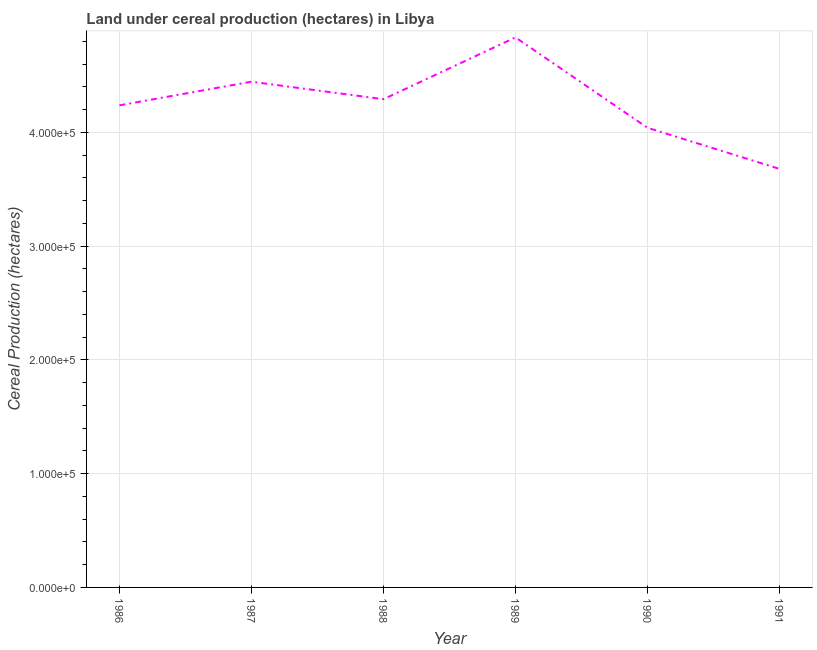What is the land under cereal production in 1989?
Provide a short and direct response. 4.84e+05. Across all years, what is the maximum land under cereal production?
Provide a short and direct response. 4.84e+05. Across all years, what is the minimum land under cereal production?
Keep it short and to the point. 3.68e+05. In which year was the land under cereal production minimum?
Your answer should be very brief. 1991. What is the sum of the land under cereal production?
Provide a succinct answer. 2.55e+06. What is the difference between the land under cereal production in 1986 and 1987?
Make the answer very short. -2.08e+04. What is the average land under cereal production per year?
Your response must be concise. 4.26e+05. What is the median land under cereal production?
Your answer should be very brief. 4.26e+05. In how many years, is the land under cereal production greater than 40000 hectares?
Your answer should be compact. 6. What is the ratio of the land under cereal production in 1986 to that in 1988?
Give a very brief answer. 0.99. Is the land under cereal production in 1986 less than that in 1988?
Provide a short and direct response. Yes. What is the difference between the highest and the second highest land under cereal production?
Provide a succinct answer. 3.90e+04. What is the difference between the highest and the lowest land under cereal production?
Your answer should be very brief. 1.16e+05. Does the land under cereal production monotonically increase over the years?
Make the answer very short. No. How many lines are there?
Your response must be concise. 1. How many years are there in the graph?
Your response must be concise. 6. What is the difference between two consecutive major ticks on the Y-axis?
Your response must be concise. 1.00e+05. Does the graph contain any zero values?
Provide a succinct answer. No. Does the graph contain grids?
Keep it short and to the point. Yes. What is the title of the graph?
Your response must be concise. Land under cereal production (hectares) in Libya. What is the label or title of the X-axis?
Provide a succinct answer. Year. What is the label or title of the Y-axis?
Keep it short and to the point. Cereal Production (hectares). What is the Cereal Production (hectares) in 1986?
Your answer should be very brief. 4.24e+05. What is the Cereal Production (hectares) in 1987?
Give a very brief answer. 4.45e+05. What is the Cereal Production (hectares) of 1988?
Make the answer very short. 4.29e+05. What is the Cereal Production (hectares) of 1989?
Offer a terse response. 4.84e+05. What is the Cereal Production (hectares) of 1990?
Your response must be concise. 4.04e+05. What is the Cereal Production (hectares) of 1991?
Your answer should be very brief. 3.68e+05. What is the difference between the Cereal Production (hectares) in 1986 and 1987?
Your answer should be very brief. -2.08e+04. What is the difference between the Cereal Production (hectares) in 1986 and 1988?
Offer a very short reply. -5386. What is the difference between the Cereal Production (hectares) in 1986 and 1989?
Offer a very short reply. -5.97e+04. What is the difference between the Cereal Production (hectares) in 1986 and 1990?
Offer a very short reply. 1.97e+04. What is the difference between the Cereal Production (hectares) in 1986 and 1991?
Offer a terse response. 5.59e+04. What is the difference between the Cereal Production (hectares) in 1987 and 1988?
Your answer should be compact. 1.54e+04. What is the difference between the Cereal Production (hectares) in 1987 and 1989?
Make the answer very short. -3.90e+04. What is the difference between the Cereal Production (hectares) in 1987 and 1990?
Make the answer very short. 4.05e+04. What is the difference between the Cereal Production (hectares) in 1987 and 1991?
Offer a very short reply. 7.66e+04. What is the difference between the Cereal Production (hectares) in 1988 and 1989?
Ensure brevity in your answer.  -5.43e+04. What is the difference between the Cereal Production (hectares) in 1988 and 1990?
Your answer should be very brief. 2.51e+04. What is the difference between the Cereal Production (hectares) in 1988 and 1991?
Give a very brief answer. 6.13e+04. What is the difference between the Cereal Production (hectares) in 1989 and 1990?
Provide a succinct answer. 7.95e+04. What is the difference between the Cereal Production (hectares) in 1989 and 1991?
Your answer should be very brief. 1.16e+05. What is the difference between the Cereal Production (hectares) in 1990 and 1991?
Provide a succinct answer. 3.61e+04. What is the ratio of the Cereal Production (hectares) in 1986 to that in 1987?
Keep it short and to the point. 0.95. What is the ratio of the Cereal Production (hectares) in 1986 to that in 1989?
Give a very brief answer. 0.88. What is the ratio of the Cereal Production (hectares) in 1986 to that in 1990?
Offer a terse response. 1.05. What is the ratio of the Cereal Production (hectares) in 1986 to that in 1991?
Your answer should be very brief. 1.15. What is the ratio of the Cereal Production (hectares) in 1987 to that in 1988?
Your answer should be very brief. 1.04. What is the ratio of the Cereal Production (hectares) in 1987 to that in 1989?
Your response must be concise. 0.92. What is the ratio of the Cereal Production (hectares) in 1987 to that in 1990?
Provide a succinct answer. 1.1. What is the ratio of the Cereal Production (hectares) in 1987 to that in 1991?
Offer a very short reply. 1.21. What is the ratio of the Cereal Production (hectares) in 1988 to that in 1989?
Offer a terse response. 0.89. What is the ratio of the Cereal Production (hectares) in 1988 to that in 1990?
Ensure brevity in your answer.  1.06. What is the ratio of the Cereal Production (hectares) in 1988 to that in 1991?
Your response must be concise. 1.17. What is the ratio of the Cereal Production (hectares) in 1989 to that in 1990?
Your answer should be very brief. 1.2. What is the ratio of the Cereal Production (hectares) in 1989 to that in 1991?
Make the answer very short. 1.31. What is the ratio of the Cereal Production (hectares) in 1990 to that in 1991?
Keep it short and to the point. 1.1. 